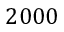<formula> <loc_0><loc_0><loc_500><loc_500>2 0 0 0</formula> 